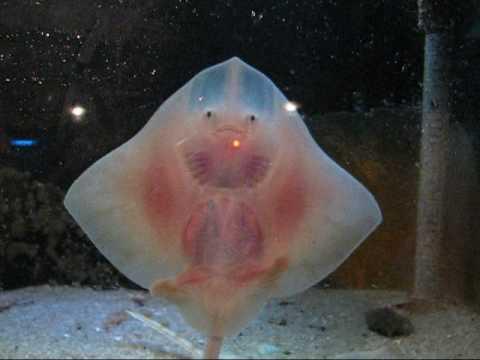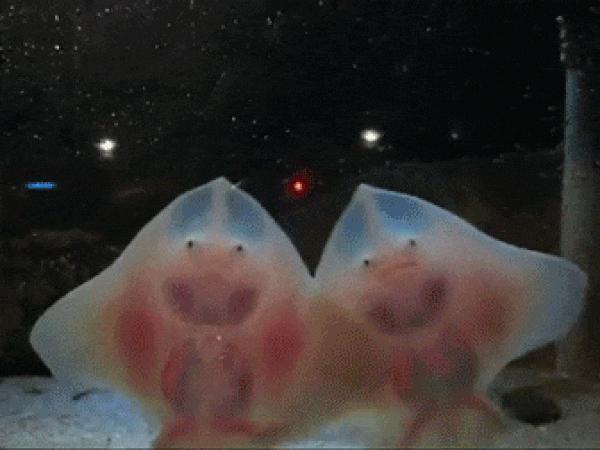The first image is the image on the left, the second image is the image on the right. For the images shown, is this caption "All of the stingrays are shown upright with undersides facing the camera and 'wings' outspread." true? Answer yes or no. Yes. The first image is the image on the left, the second image is the image on the right. Analyze the images presented: Is the assertion "A single ray presses its body against the glass in each of the images." valid? Answer yes or no. No. 